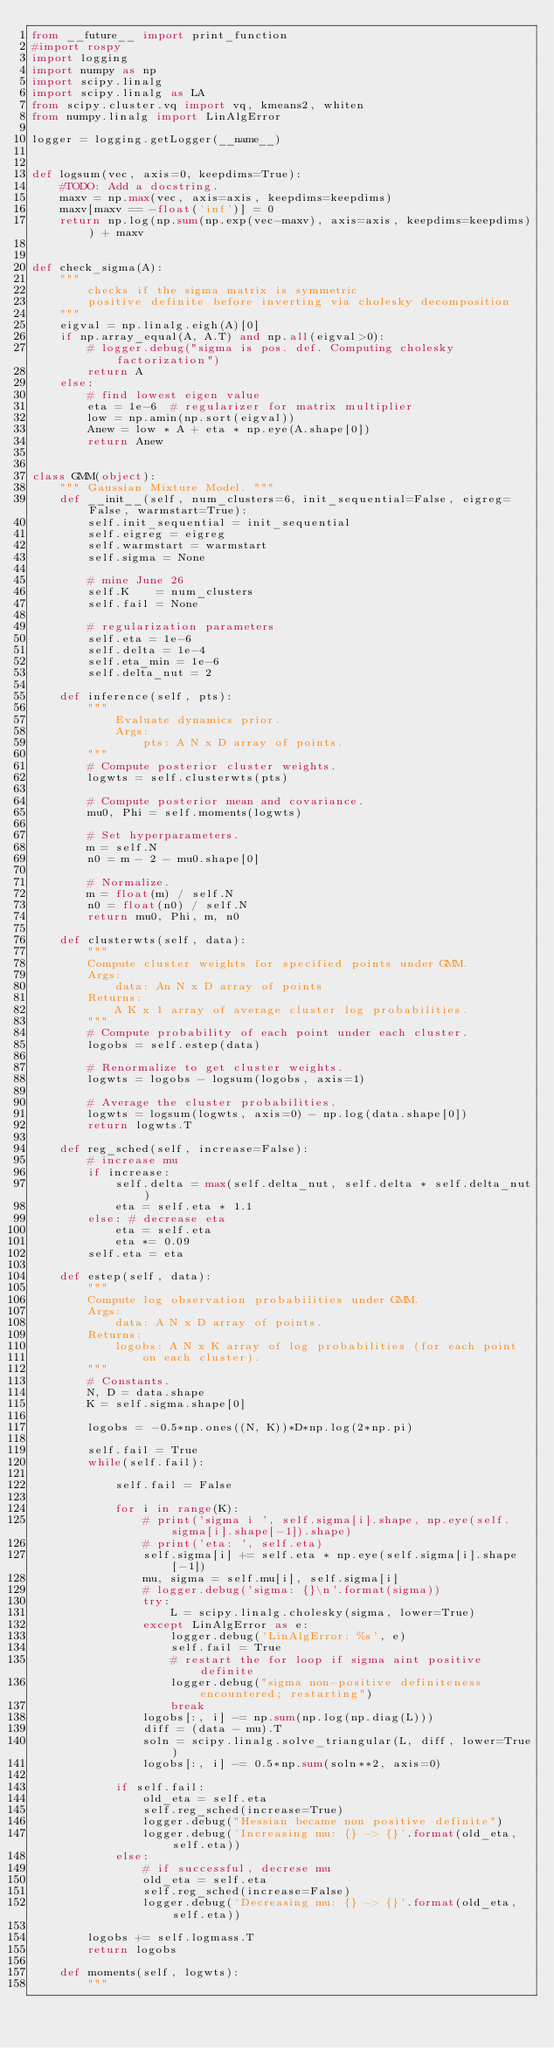Convert code to text. <code><loc_0><loc_0><loc_500><loc_500><_Python_>from __future__ import print_function
#import rospy
import logging
import numpy as np
import scipy.linalg
import scipy.linalg as LA
from scipy.cluster.vq import vq, kmeans2, whiten
from numpy.linalg import LinAlgError

logger = logging.getLogger(__name__)


def logsum(vec, axis=0, keepdims=True):
    #TODO: Add a docstring.
    maxv = np.max(vec, axis=axis, keepdims=keepdims)
    maxv[maxv == -float('inf')] = 0
    return np.log(np.sum(np.exp(vec-maxv), axis=axis, keepdims=keepdims)) + maxv


def check_sigma(A):
    """
        checks if the sigma matrix is symmetric
        positive definite before inverting via cholesky decomposition
    """
    eigval = np.linalg.eigh(A)[0]
    if np.array_equal(A, A.T) and np.all(eigval>0):
        # logger.debug("sigma is pos. def. Computing cholesky factorization")
        return A
    else:
        # find lowest eigen value
        eta = 1e-6  # regularizer for matrix multiplier
        low = np.amin(np.sort(eigval))
        Anew = low * A + eta * np.eye(A.shape[0])
        return Anew


class GMM(object):
    """ Gaussian Mixture Model. """
    def __init__(self, num_clusters=6, init_sequential=False, eigreg=False, warmstart=True):
        self.init_sequential = init_sequential
        self.eigreg = eigreg
        self.warmstart = warmstart
        self.sigma = None

        # mine June 26
        self.K    = num_clusters
        self.fail = None

        # regularization parameters
        self.eta = 1e-6
        self.delta = 1e-4
        self.eta_min = 1e-6
        self.delta_nut = 2

    def inference(self, pts):
        """
            Evaluate dynamics prior.
            Args:
                pts: A N x D array of points.
        """
        # Compute posterior cluster weights.
        logwts = self.clusterwts(pts)

        # Compute posterior mean and covariance.
        mu0, Phi = self.moments(logwts)

        # Set hyperparameters.
        m = self.N
        n0 = m - 2 - mu0.shape[0]

        # Normalize.
        m = float(m) / self.N
        n0 = float(n0) / self.N
        return mu0, Phi, m, n0

    def clusterwts(self, data):
        """
        Compute cluster weights for specified points under GMM.
        Args:
            data: An N x D array of points
        Returns:
            A K x 1 array of average cluster log probabilities.
        """
        # Compute probability of each point under each cluster.
        logobs = self.estep(data)

        # Renormalize to get cluster weights.
        logwts = logobs - logsum(logobs, axis=1)

        # Average the cluster probabilities.
        logwts = logsum(logwts, axis=0) - np.log(data.shape[0])
        return logwts.T

    def reg_sched(self, increase=False):
        # increase mu
        if increase:
            self.delta = max(self.delta_nut, self.delta * self.delta_nut)
            eta = self.eta * 1.1
        else: # decrease eta
            eta = self.eta
            eta *= 0.09
        self.eta = eta

    def estep(self, data):
        """
        Compute log observation probabilities under GMM.
        Args:
            data: A N x D array of points.
        Returns:
            logobs: A N x K array of log probabilities (for each point
                on each cluster).
        """
        # Constants.
        N, D = data.shape
        K = self.sigma.shape[0]

        logobs = -0.5*np.ones((N, K))*D*np.log(2*np.pi)

        self.fail = True
        while(self.fail):

            self.fail = False

            for i in range(K):
                # print('sigma i ', self.sigma[i].shape, np.eye(self.sigma[i].shape[-1]).shape)
                # print('eta: ', self.eta)
                self.sigma[i] += self.eta * np.eye(self.sigma[i].shape[-1])
                mu, sigma = self.mu[i], self.sigma[i]
                # logger.debug('sigma: {}\n'.format(sigma))
                try:
                    L = scipy.linalg.cholesky(sigma, lower=True)
                except LinAlgError as e:
                    logger.debug('LinAlgError: %s', e)
                    self.fail = True
                    # restart the for loop if sigma aint positive definite
                    logger.debug("sigma non-positive definiteness encountered; restarting")
                    break
                logobs[:, i] -= np.sum(np.log(np.diag(L)))
                diff = (data - mu).T
                soln = scipy.linalg.solve_triangular(L, diff, lower=True)
                logobs[:, i] -= 0.5*np.sum(soln**2, axis=0)

            if self.fail:
                old_eta = self.eta
                self.reg_sched(increase=True)
                logger.debug("Hessian became non positive definite")
                logger.debug('Increasing mu: {} -> {}'.format(old_eta, self.eta))
            else:
                # if successful, decrese mu
                old_eta = self.eta
                self.reg_sched(increase=False)
                logger.debug('Decreasing mu: {} -> {}'.format(old_eta, self.eta))

        logobs += self.logmass.T
        return logobs

    def moments(self, logwts):
        """</code> 